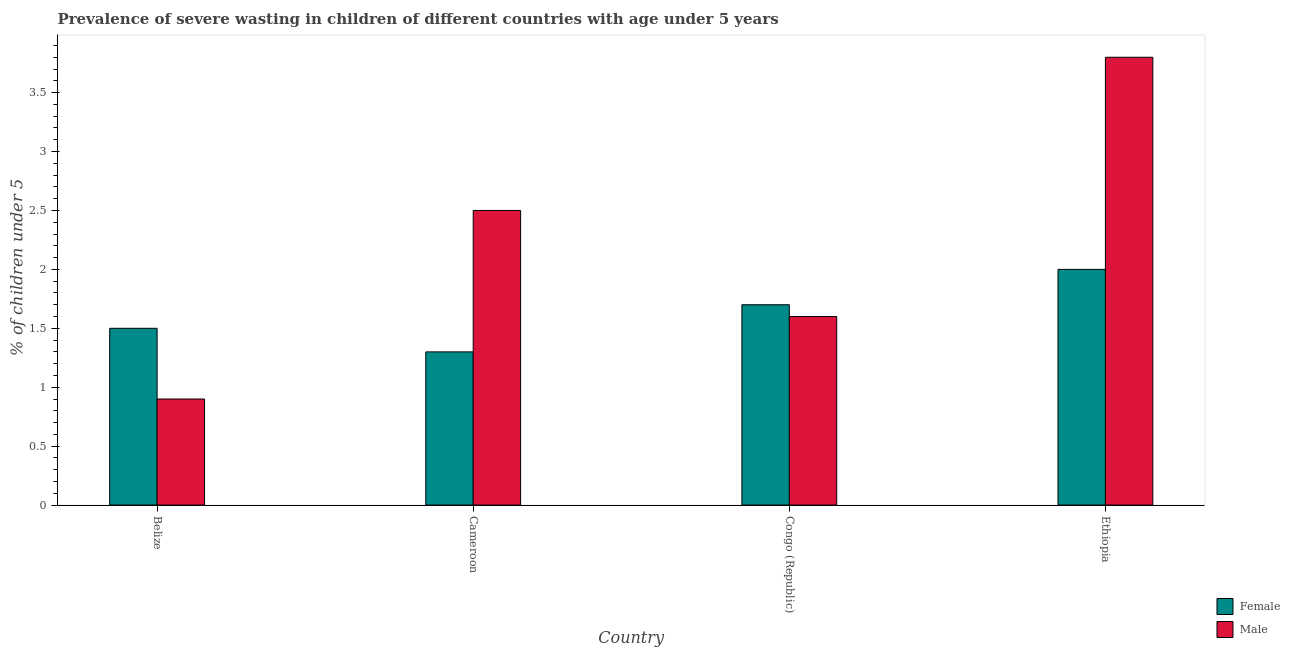How many different coloured bars are there?
Make the answer very short. 2. How many groups of bars are there?
Offer a very short reply. 4. Are the number of bars on each tick of the X-axis equal?
Ensure brevity in your answer.  Yes. What is the label of the 2nd group of bars from the left?
Your answer should be very brief. Cameroon. What is the percentage of undernourished female children in Congo (Republic)?
Your answer should be compact. 1.7. Across all countries, what is the maximum percentage of undernourished male children?
Your response must be concise. 3.8. Across all countries, what is the minimum percentage of undernourished female children?
Your response must be concise. 1.3. In which country was the percentage of undernourished male children maximum?
Your response must be concise. Ethiopia. In which country was the percentage of undernourished female children minimum?
Your response must be concise. Cameroon. What is the total percentage of undernourished female children in the graph?
Ensure brevity in your answer.  6.5. What is the difference between the percentage of undernourished male children in Belize and that in Congo (Republic)?
Make the answer very short. -0.7. What is the difference between the percentage of undernourished male children in Congo (Republic) and the percentage of undernourished female children in Ethiopia?
Provide a short and direct response. -0.4. What is the average percentage of undernourished female children per country?
Make the answer very short. 1.62. What is the difference between the percentage of undernourished male children and percentage of undernourished female children in Congo (Republic)?
Your answer should be very brief. -0.1. What is the ratio of the percentage of undernourished female children in Cameroon to that in Congo (Republic)?
Your response must be concise. 0.76. What is the difference between the highest and the second highest percentage of undernourished female children?
Make the answer very short. 0.3. What is the difference between the highest and the lowest percentage of undernourished male children?
Offer a terse response. 2.9. In how many countries, is the percentage of undernourished female children greater than the average percentage of undernourished female children taken over all countries?
Provide a short and direct response. 2. Is the sum of the percentage of undernourished female children in Belize and Congo (Republic) greater than the maximum percentage of undernourished male children across all countries?
Give a very brief answer. No. What does the 2nd bar from the left in Belize represents?
Provide a succinct answer. Male. What does the 2nd bar from the right in Ethiopia represents?
Your response must be concise. Female. What is the difference between two consecutive major ticks on the Y-axis?
Provide a succinct answer. 0.5. Are the values on the major ticks of Y-axis written in scientific E-notation?
Make the answer very short. No. Does the graph contain grids?
Your answer should be very brief. No. Where does the legend appear in the graph?
Your answer should be very brief. Bottom right. What is the title of the graph?
Your answer should be compact. Prevalence of severe wasting in children of different countries with age under 5 years. Does "Official aid received" appear as one of the legend labels in the graph?
Offer a terse response. No. What is the label or title of the Y-axis?
Ensure brevity in your answer.   % of children under 5. What is the  % of children under 5 of Female in Belize?
Your response must be concise. 1.5. What is the  % of children under 5 of Male in Belize?
Provide a short and direct response. 0.9. What is the  % of children under 5 in Female in Cameroon?
Your response must be concise. 1.3. What is the  % of children under 5 in Female in Congo (Republic)?
Provide a succinct answer. 1.7. What is the  % of children under 5 of Male in Congo (Republic)?
Offer a terse response. 1.6. What is the  % of children under 5 of Male in Ethiopia?
Your answer should be very brief. 3.8. Across all countries, what is the maximum  % of children under 5 in Male?
Your response must be concise. 3.8. Across all countries, what is the minimum  % of children under 5 in Female?
Provide a short and direct response. 1.3. Across all countries, what is the minimum  % of children under 5 in Male?
Your response must be concise. 0.9. What is the total  % of children under 5 of Female in the graph?
Your answer should be compact. 6.5. What is the difference between the  % of children under 5 in Female in Belize and that in Congo (Republic)?
Ensure brevity in your answer.  -0.2. What is the difference between the  % of children under 5 in Male in Belize and that in Congo (Republic)?
Your answer should be compact. -0.7. What is the difference between the  % of children under 5 in Female in Congo (Republic) and that in Ethiopia?
Keep it short and to the point. -0.3. What is the difference between the  % of children under 5 in Male in Congo (Republic) and that in Ethiopia?
Ensure brevity in your answer.  -2.2. What is the difference between the  % of children under 5 of Female in Belize and the  % of children under 5 of Male in Congo (Republic)?
Your answer should be very brief. -0.1. What is the difference between the  % of children under 5 in Female in Congo (Republic) and the  % of children under 5 in Male in Ethiopia?
Your response must be concise. -2.1. What is the average  % of children under 5 of Female per country?
Offer a terse response. 1.62. What is the average  % of children under 5 in Male per country?
Make the answer very short. 2.2. What is the difference between the  % of children under 5 in Female and  % of children under 5 in Male in Belize?
Your answer should be very brief. 0.6. What is the difference between the  % of children under 5 in Female and  % of children under 5 in Male in Cameroon?
Your response must be concise. -1.2. What is the ratio of the  % of children under 5 in Female in Belize to that in Cameroon?
Provide a short and direct response. 1.15. What is the ratio of the  % of children under 5 in Male in Belize to that in Cameroon?
Provide a succinct answer. 0.36. What is the ratio of the  % of children under 5 in Female in Belize to that in Congo (Republic)?
Your answer should be compact. 0.88. What is the ratio of the  % of children under 5 in Male in Belize to that in Congo (Republic)?
Ensure brevity in your answer.  0.56. What is the ratio of the  % of children under 5 of Female in Belize to that in Ethiopia?
Your answer should be very brief. 0.75. What is the ratio of the  % of children under 5 of Male in Belize to that in Ethiopia?
Provide a succinct answer. 0.24. What is the ratio of the  % of children under 5 of Female in Cameroon to that in Congo (Republic)?
Your answer should be compact. 0.76. What is the ratio of the  % of children under 5 in Male in Cameroon to that in Congo (Republic)?
Ensure brevity in your answer.  1.56. What is the ratio of the  % of children under 5 of Female in Cameroon to that in Ethiopia?
Make the answer very short. 0.65. What is the ratio of the  % of children under 5 of Male in Cameroon to that in Ethiopia?
Provide a succinct answer. 0.66. What is the ratio of the  % of children under 5 of Male in Congo (Republic) to that in Ethiopia?
Offer a terse response. 0.42. What is the difference between the highest and the second highest  % of children under 5 in Female?
Ensure brevity in your answer.  0.3. What is the difference between the highest and the lowest  % of children under 5 of Female?
Offer a very short reply. 0.7. 